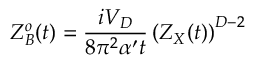Convert formula to latex. <formula><loc_0><loc_0><loc_500><loc_500>Z _ { B } ^ { o } ( t ) = { \frac { i V _ { D } } { 8 \pi ^ { 2 } \alpha ^ { \prime } t } } \left ( Z _ { X } ( t ) \right ) ^ { D - 2 }</formula> 